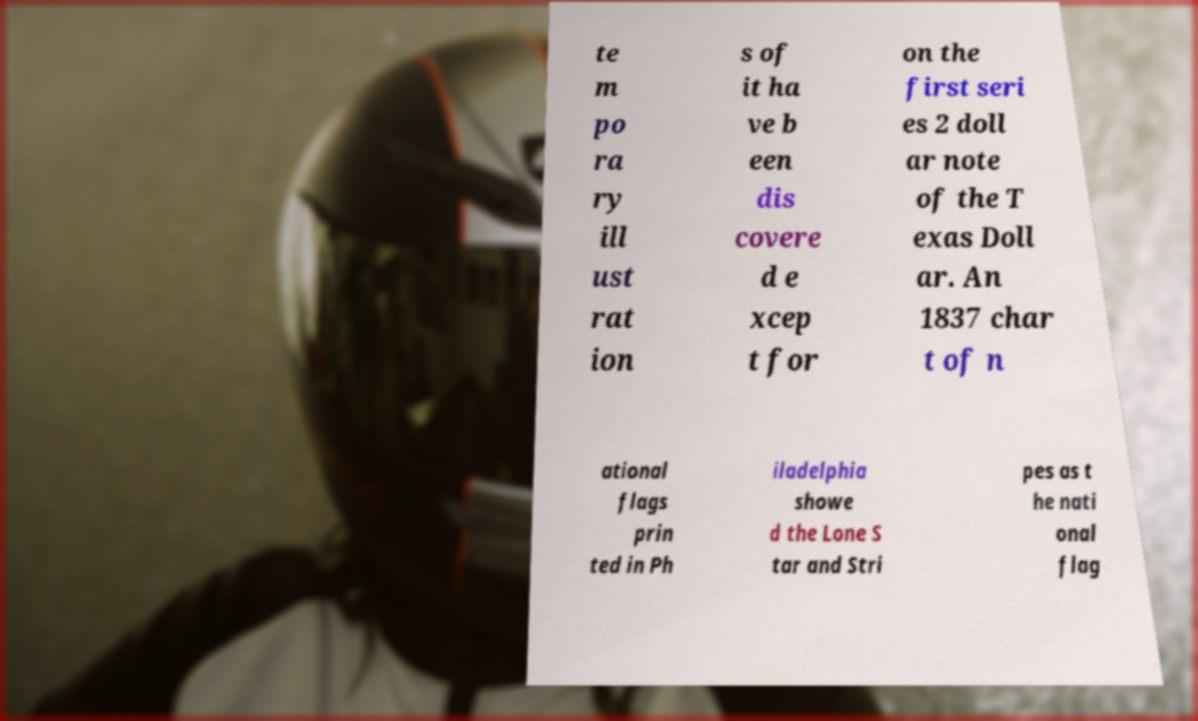Can you accurately transcribe the text from the provided image for me? te m po ra ry ill ust rat ion s of it ha ve b een dis covere d e xcep t for on the first seri es 2 doll ar note of the T exas Doll ar. An 1837 char t of n ational flags prin ted in Ph iladelphia showe d the Lone S tar and Stri pes as t he nati onal flag 